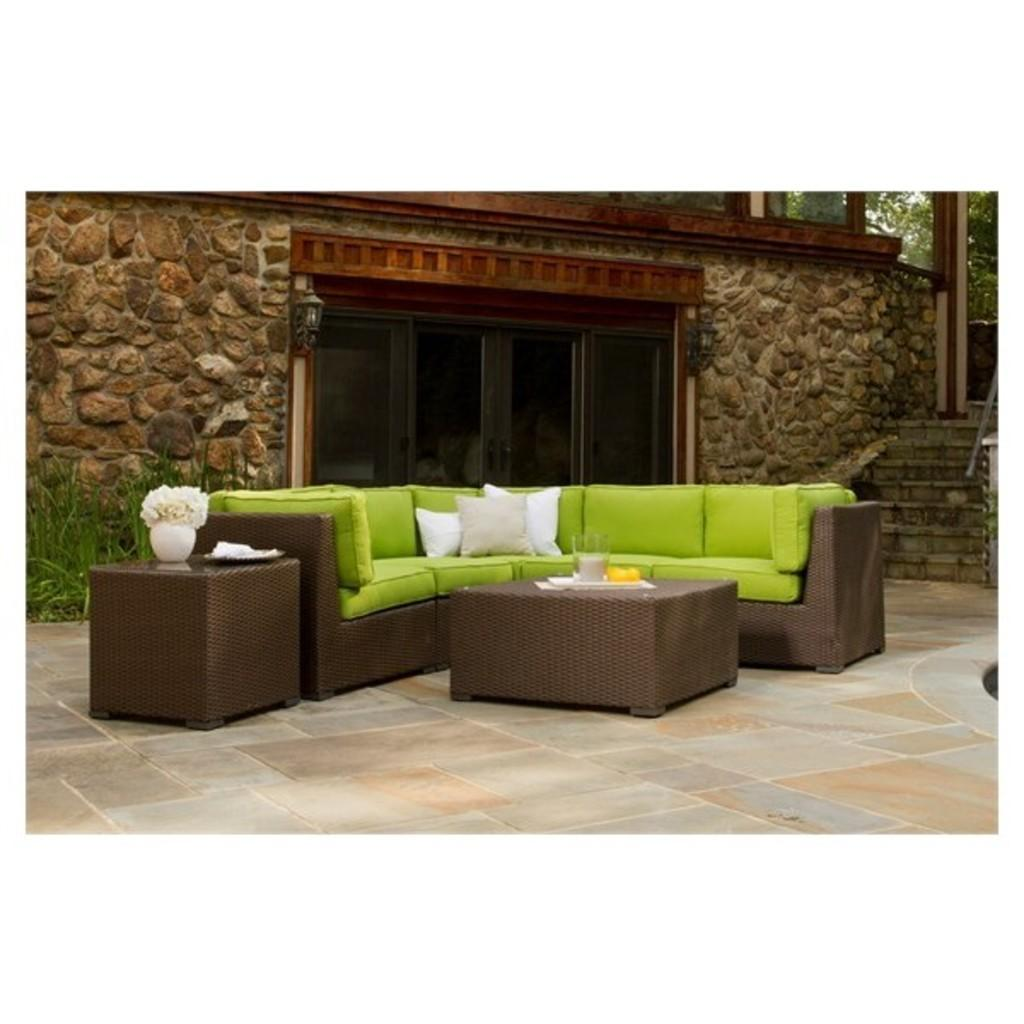What is on the table in the image? There is a flower vase on the table. What type of furniture is in the image? There is a sofa in the image. What is the background of the image made of? There is a wall in the image. What is providing illumination in the image? There is a light in the image. What type of greenery is present in the image? There are plants in the image. What type of lace can be seen on the sofa in the image? There is no lace visible on the sofa in the image. What caption is written on the wall in the image? There is no caption written on the wall in the image. 